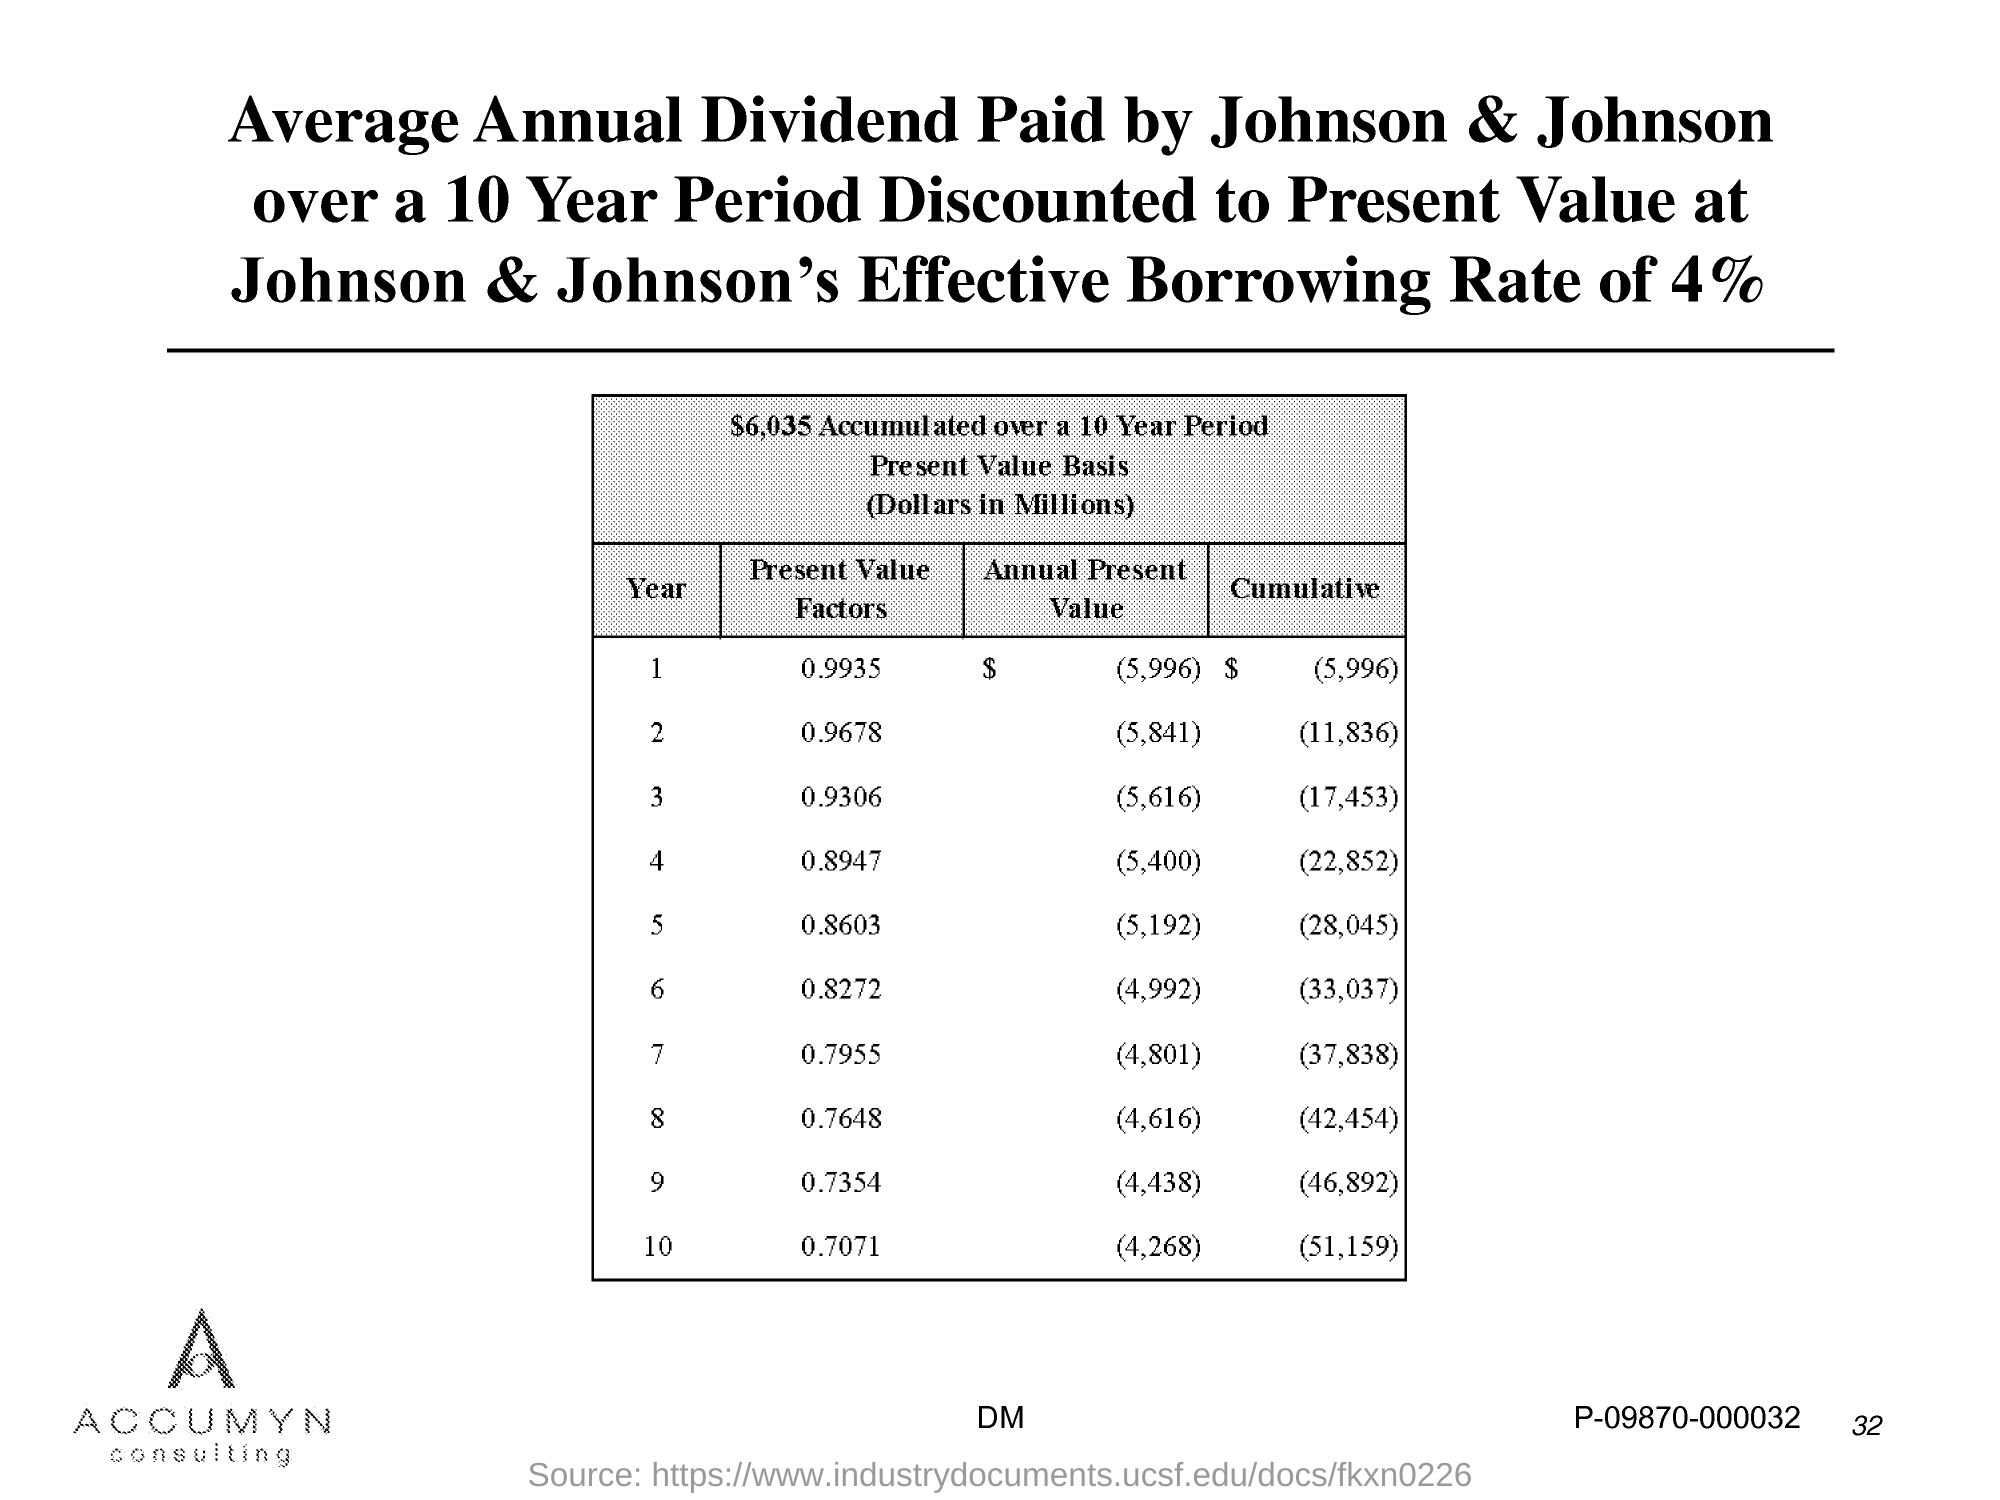What is the Page Number?
Provide a succinct answer. 32. 